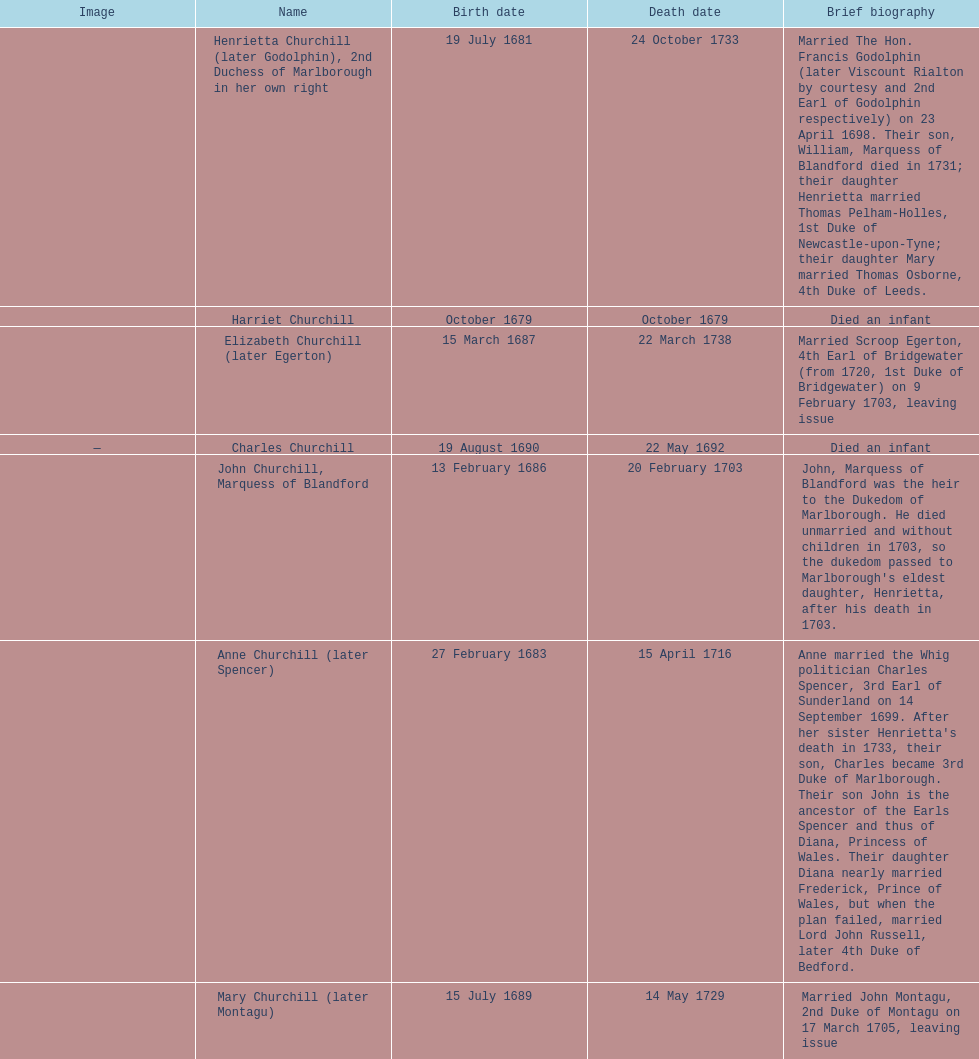Who was born before henrietta churchhill? Harriet Churchill. 